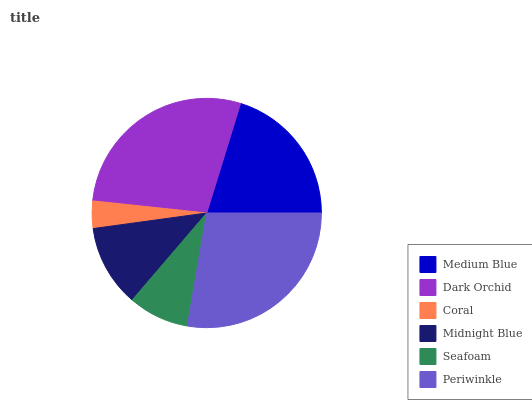Is Coral the minimum?
Answer yes or no. Yes. Is Dark Orchid the maximum?
Answer yes or no. Yes. Is Dark Orchid the minimum?
Answer yes or no. No. Is Coral the maximum?
Answer yes or no. No. Is Dark Orchid greater than Coral?
Answer yes or no. Yes. Is Coral less than Dark Orchid?
Answer yes or no. Yes. Is Coral greater than Dark Orchid?
Answer yes or no. No. Is Dark Orchid less than Coral?
Answer yes or no. No. Is Medium Blue the high median?
Answer yes or no. Yes. Is Midnight Blue the low median?
Answer yes or no. Yes. Is Midnight Blue the high median?
Answer yes or no. No. Is Seafoam the low median?
Answer yes or no. No. 